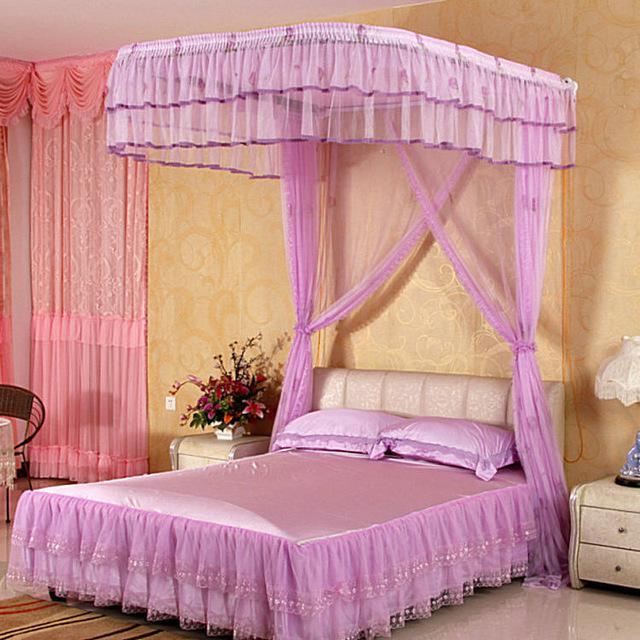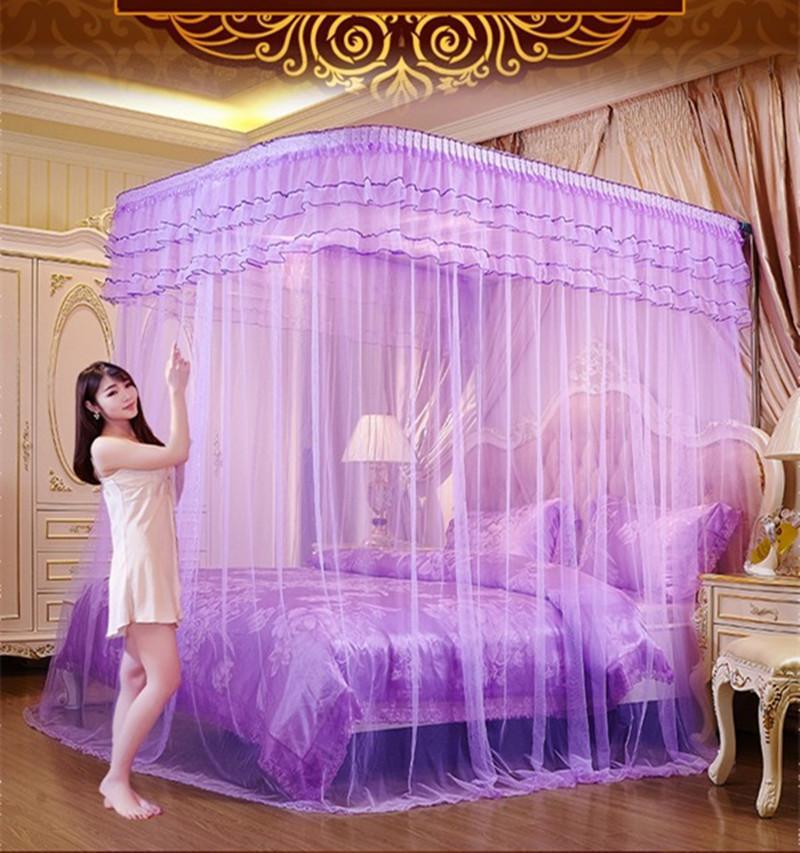The first image is the image on the left, the second image is the image on the right. Evaluate the accuracy of this statement regarding the images: "The left and right image contains the same number of purple canopies.". Is it true? Answer yes or no. Yes. The first image is the image on the left, the second image is the image on the right. Given the left and right images, does the statement "Each image shows a bed with purple ruffled layers above it, and one of the images shows sheer purple draping at least two sides of the bed from a canopy the same shape as the bed." hold true? Answer yes or no. Yes. 